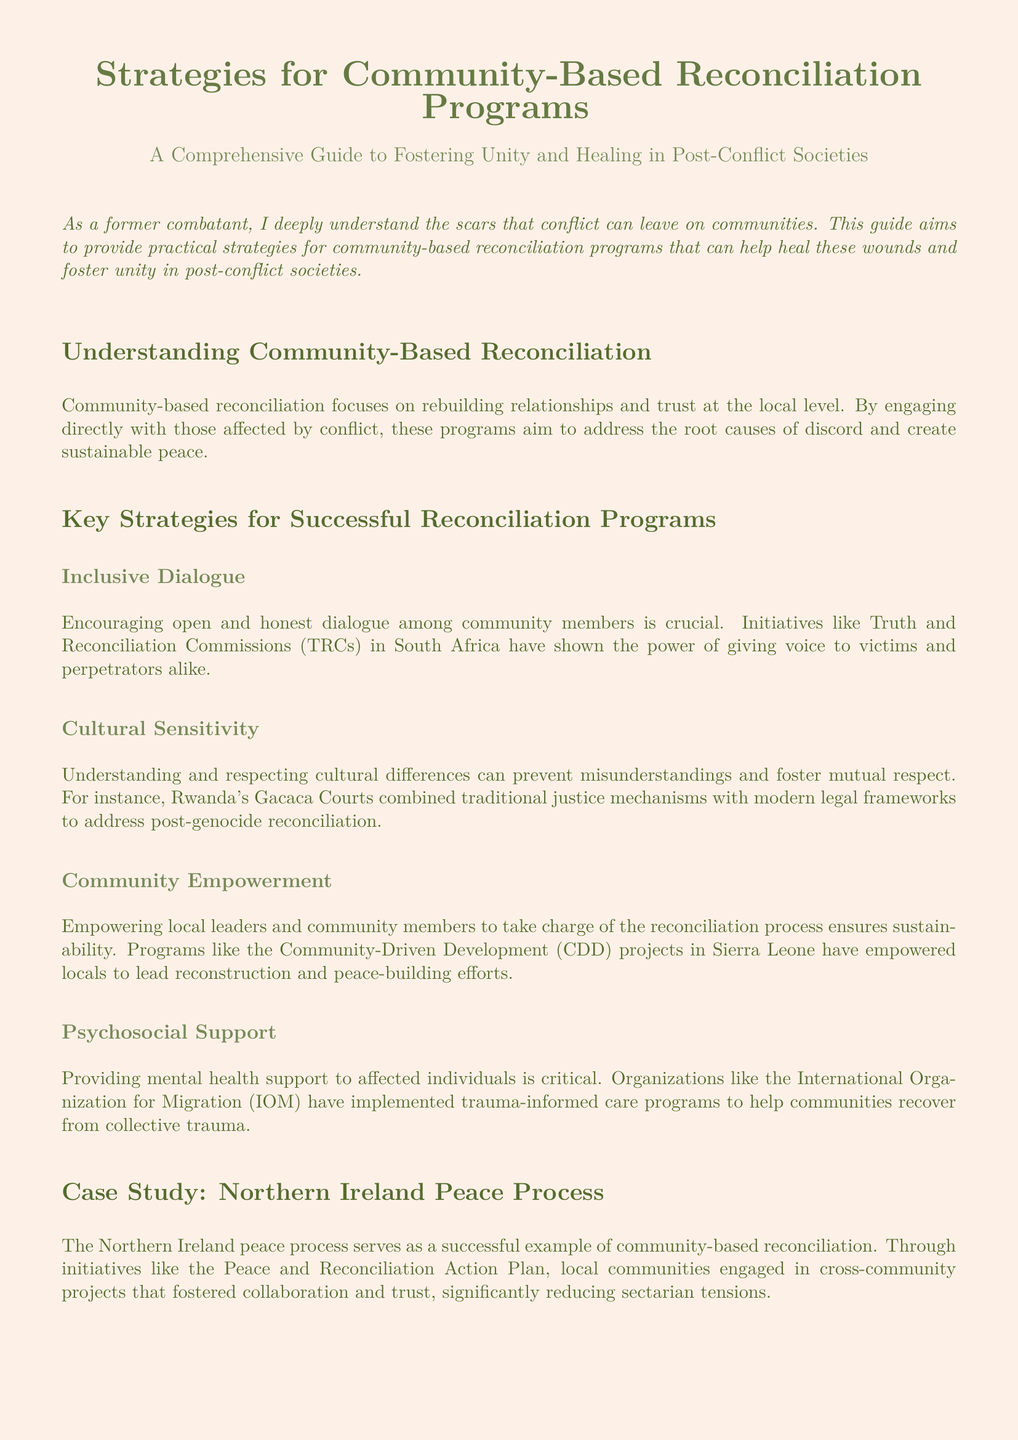What is the focus of community-based reconciliation? The document states that community-based reconciliation focuses on rebuilding relationships and trust at the local level.
Answer: Rebuilding relationships and trust What initiative is mentioned as a successful example of inclusive dialogue? The document refers to Truth and Reconciliation Commissions (TRCs) in South Africa as a successful example.
Answer: Truth and Reconciliation Commissions Which program in Sierra Leone empowered locals to lead reconstruction? The document mentions Community-Driven Development (CDD) projects in Sierra Leone.
Answer: Community-Driven Development What type of support is critical for affected individuals? The document highlights the importance of providing mental health support.
Answer: Mental health support What was a significant outcome of the Northern Ireland peace process? The document states that it significantly reduced sectarian tensions.
Answer: Reduced sectarian tensions 